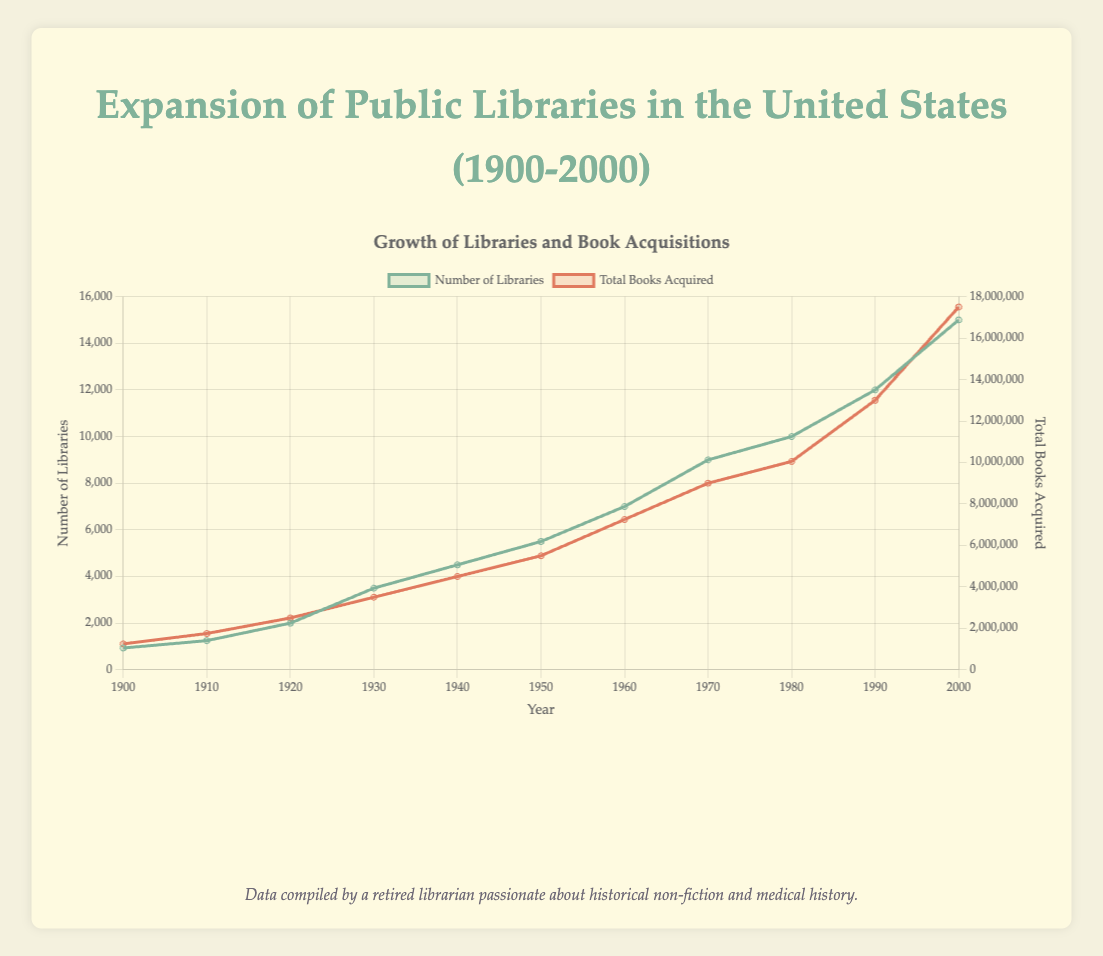When did the number of libraries first exceed 5,000? The figure shows the number of libraries over time. By observing the plot, we see that the number of libraries first exceeds 5,000 between 1940 and 1950.
Answer: 1950 How many total books were acquired between 1920 and 1930? The data for total books acquired in 1920 is 2,500,000 and in 1930 is 3,500,000. Therefore, the number of books acquired between these years is 3,500,000 - 2,500,000 = 1,000,000 books.
Answer: 1,000,000 Between which two consecutive decades did the number of libraries increase the most? And by how much? Observing the number of libraries in consecutive decades: (1,250 - 934), (2,000 - 1,250), (3,500 - 2,000), (4,500 - 3,500), (5,500 - 4,500), (7,000 - 5,500), (9,000 - 7,000), (10,000 - 9,000), (12,000 - 10,000), (15,000 - 12,000). We notice the largest increase occurs between 1930 to 1940, with an increase of 2,500 libraries.
Answer: From 1920 to 1930, by 1,500 libraries How would you describe the trend in the total number of books acquired after 1950? By looking at the plot, we can observe that the total number of books shows a steady increase after 1950, rising continuously without any decreases.
Answer: A steady increase Which year shows the largest single-year increase in the number of libraries? Examining the data points for the number of libraries, the largest increase occurred between 1920 (2,000 libraries) and 1930 (3,500 libraries), which represents the largest single-decade increase observed in the figure.
Answer: 1930 What color represents the 'Total Books Acquired' line in the plot? The figure shows two lines with different colors. The 'Total Books Acquired' line is represented in red.
Answer: Red If the trend from 1990 to 2000 continued, estimate the number of total books acquired by 2010. The total number of books acquired in 1990 is 13,000,000 and in 2000 is 17,500,000. The increase over this decade is 4,500,000 books. If the same trend continues for the next decade, the estimate for 2010 would be 17,500,000 + 4,500,000 = 22,000,000 books.
Answer: 22,000,000 books By how much did the number of libraries increase per year on average from 1950 to 2000? The number of libraries in 1950 is 5,500 and in 2000 is 15,000. So, over 50 years, the increase is 15,000 - 5,500 = 9,500 libraries. The average annual increase is 9,500 / 50 = 190 libraries per year.
Answer: 190 libraries per year 